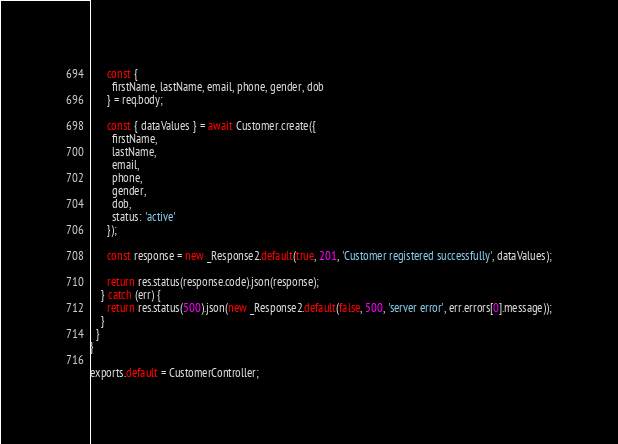<code> <loc_0><loc_0><loc_500><loc_500><_JavaScript_>      const {
        firstName, lastName, email, phone, gender, dob
      } = req.body;

      const { dataValues } = await Customer.create({
        firstName,
        lastName,
        email,
        phone,
        gender,
        dob,
        status: 'active'
      });

      const response = new _Response2.default(true, 201, 'Customer registered successfully', dataValues);

      return res.status(response.code).json(response);
    } catch (err) {
      return res.status(500).json(new _Response2.default(false, 500, 'server error', err.errors[0].message));
    }
  }
}

exports.default = CustomerController;</code> 